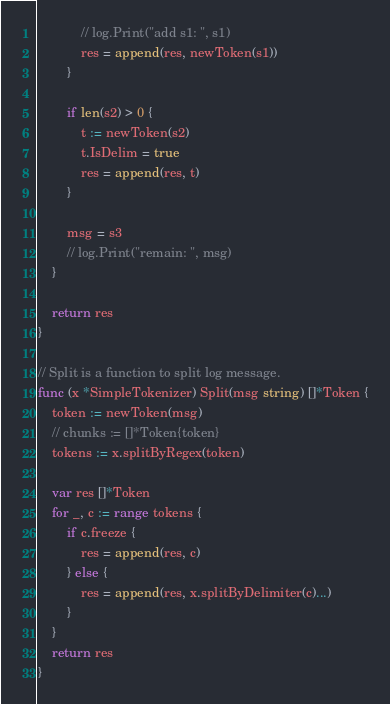<code> <loc_0><loc_0><loc_500><loc_500><_Go_>			// log.Print("add s1: ", s1)
			res = append(res, newToken(s1))
		}

		if len(s2) > 0 {
			t := newToken(s2)
			t.IsDelim = true
			res = append(res, t)
		}

		msg = s3
		// log.Print("remain: ", msg)
	}

	return res
}

// Split is a function to split log message.
func (x *SimpleTokenizer) Split(msg string) []*Token {
	token := newToken(msg)
	// chunks := []*Token{token}
	tokens := x.splitByRegex(token)

	var res []*Token
	for _, c := range tokens {
		if c.freeze {
			res = append(res, c)
		} else {
			res = append(res, x.splitByDelimiter(c)...)
		}
	}
	return res
}
</code> 